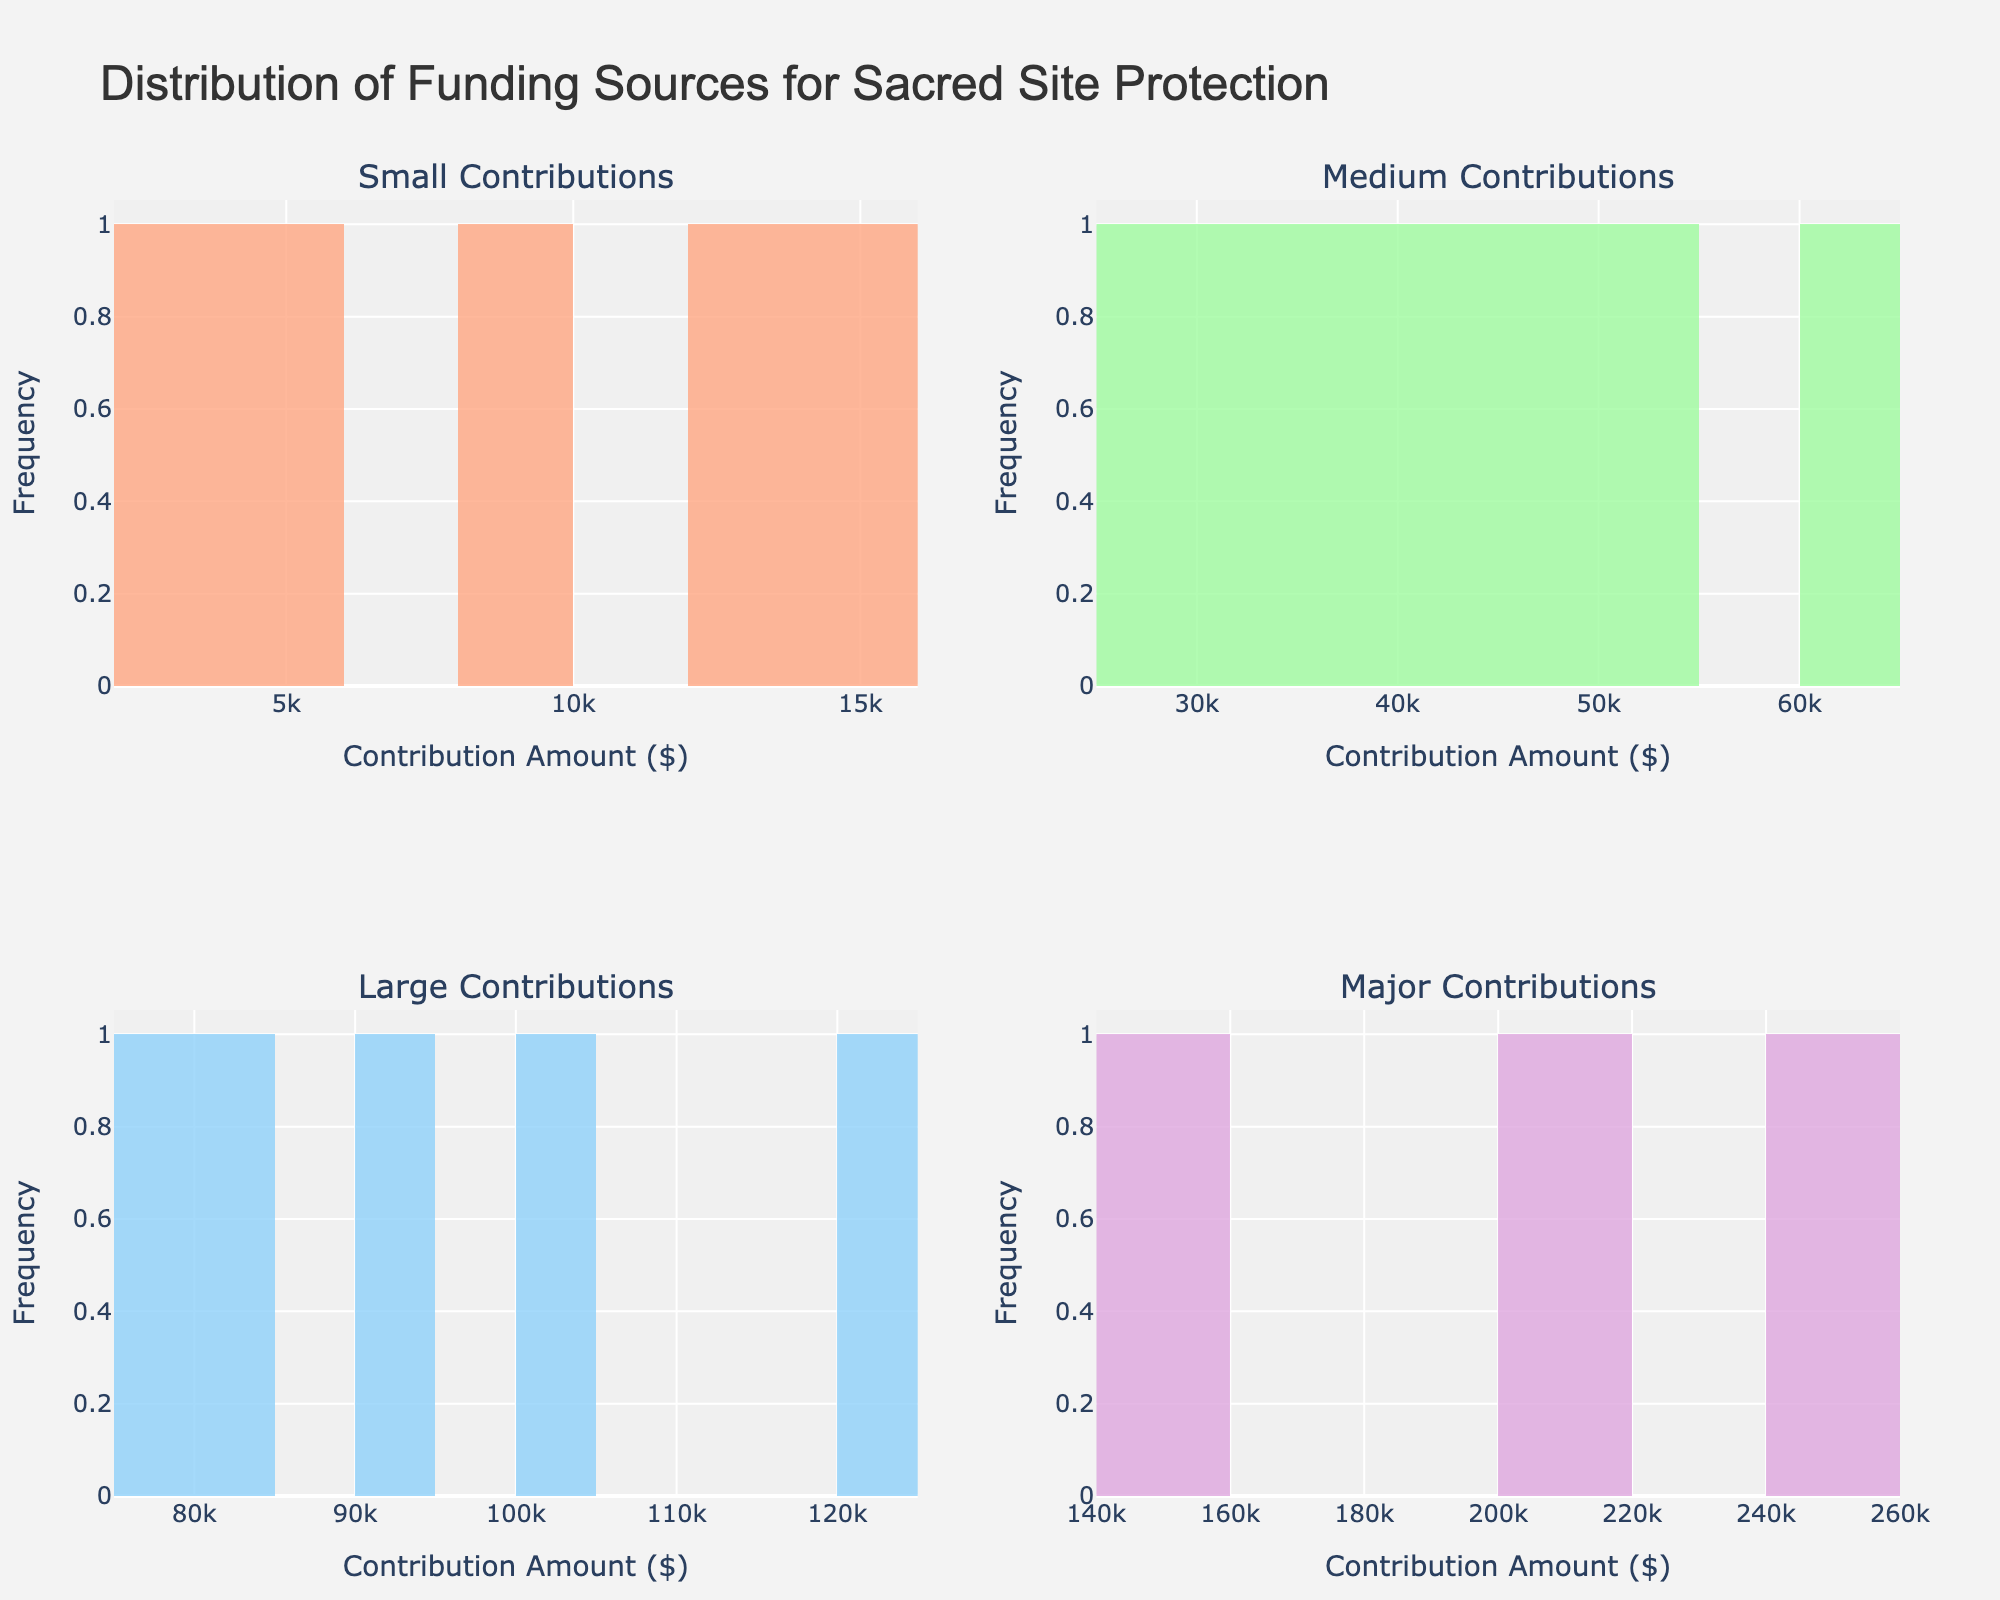How many different categories of contributions are displayed in the figure? There are four subplot titles, each representing a different category of contributions. These titles are "Small Contributions," "Medium Contributions," "Large Contributions," and "Major Contributions."
Answer: Four What is the title of the figure? The title of the figure can be read directly from the top of the chart. It states "Distribution of Funding Sources for Sacred Site Protection."
Answer: Distribution of Funding Sources for Sacred Site Protection Which contribution category has the highest single contribution amount? By examining the x-axis of each subplot, it is evident that "Major Contributions" include amounts as high as $250,000, which is the highest among all categories.
Answer: Major Contributions In the "Medium Contributions" category, how many subplots are there? The "Medium Contributions" is one of the subplot titles, and subplots refer to each individual chart within the main figure. Therefore, there is only one "Medium Contributions" subplot.
Answer: One What's the common x-axis title across all subplots? The x-axis title, represented at the bottom of each subplot, reads "Contribution Amount ($)" for all subplots.
Answer: Contribution Amount ($) What is the color used for the "Large Contributions" histogram? The "Large Contributions" histogram can be identified by its subplot title. The color of the bars in this subplot is light blue.
Answer: Light blue How does the count of donations in the "Small Contributions" category compare to the count in "Major Contributions"? By counting the bars and their heights in both "Small Contributions" and "Major Contributions" subplots, it can be observed that "Small Contributions" has more donation counts as there are more bars with higher frequencies.
Answer: Small Contributions has more donations What is the range of contribution amounts in the "Government Grants" under the "Major Contributions" category? The "Government Grants" in the "Major Contributions" category would fall on the x-axis values for this subplot. The range of the amounts shown is from $150,000 to $200,000.
Answer: $150,000 to $200,000 Are there more medium contributions (all types) or large contributions (all types)? By looking at the frequencies and number of bars in both the "Medium Contributions" and "Large Contributions" subplots, it is visible that "Medium Contributions" has more data points and higher frequencies collectively.
Answer: Medium Contributions 